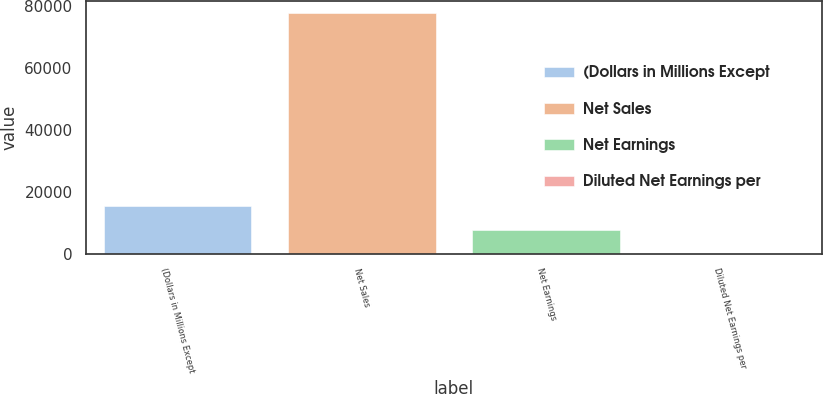Convert chart to OTSL. <chart><loc_0><loc_0><loc_500><loc_500><bar_chart><fcel>(Dollars in Millions Except<fcel>Net Sales<fcel>Net Earnings<fcel>Diluted Net Earnings per<nl><fcel>15536.6<fcel>77681<fcel>7768.6<fcel>0.55<nl></chart> 